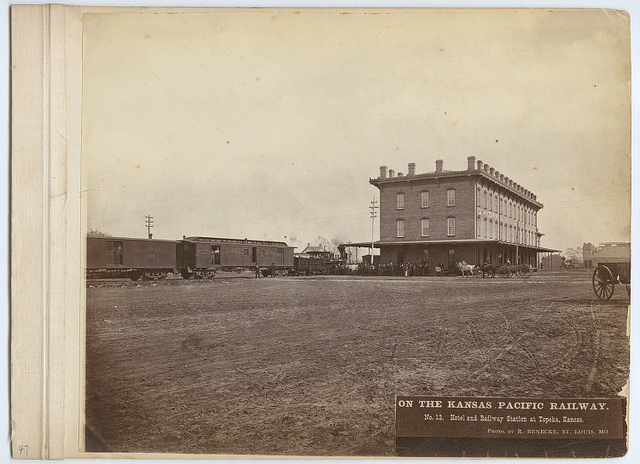Read all the text in this image. ON THE KANSAS PACIFIC RAILWAY 